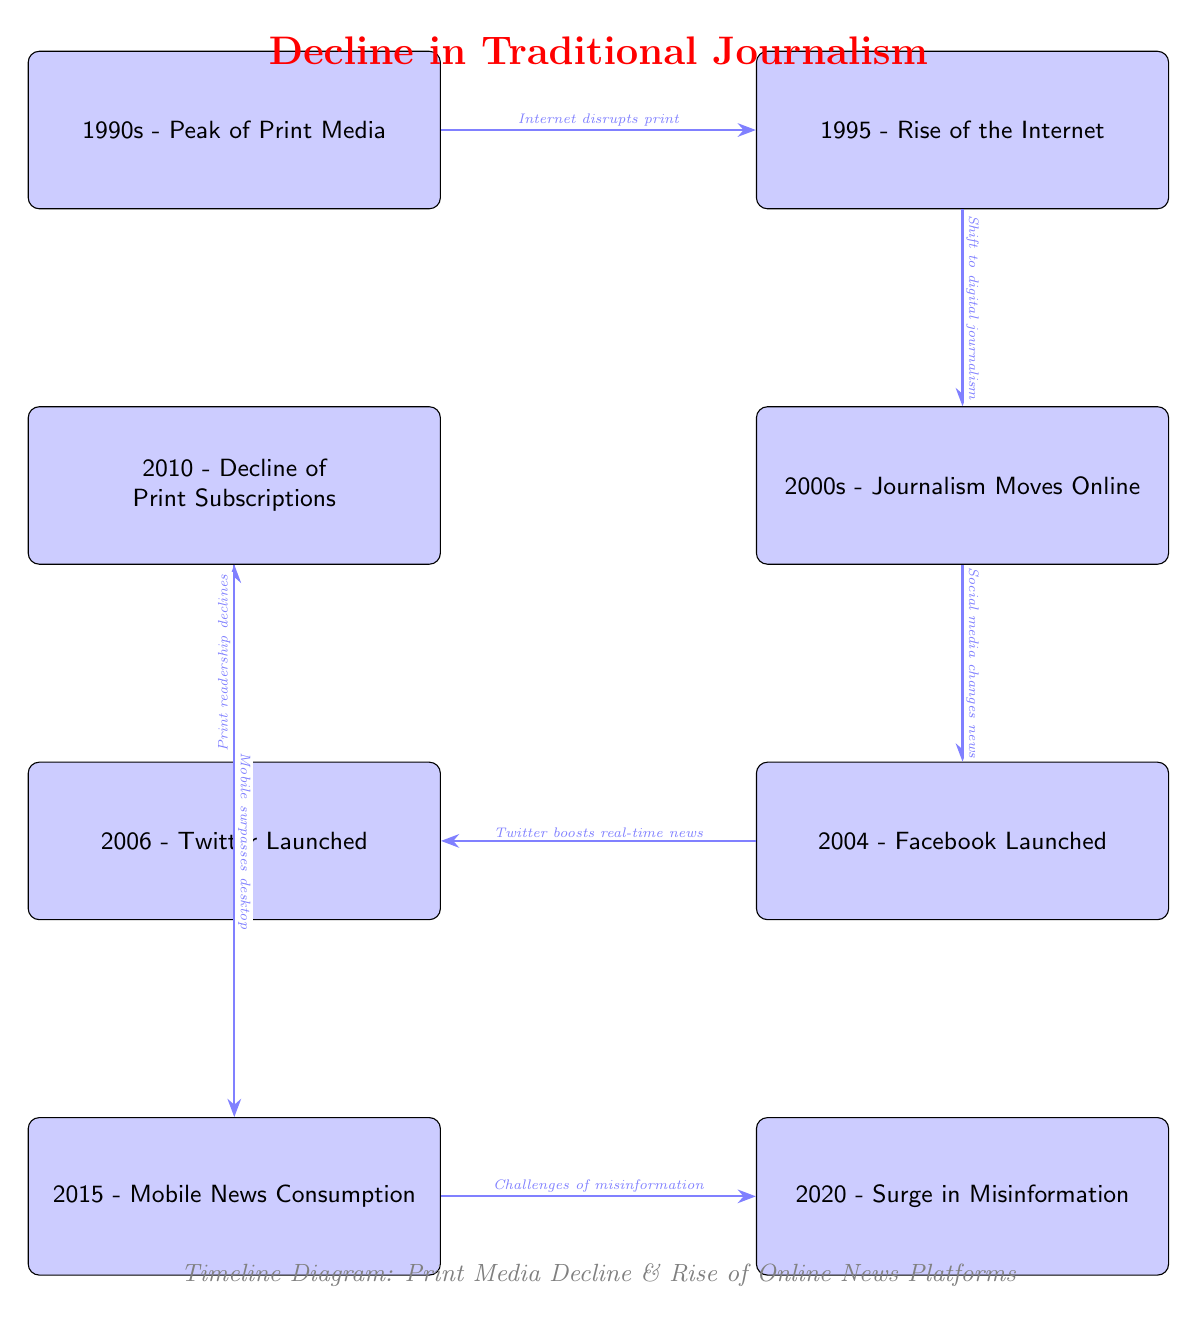What year did the rise of the Internet occur? The diagram shows a timeline with the event "Rise of the Internet" marked in the year 1995. This event is positioned directly to the right of the "Peak of Print Media" in the timeline.
Answer: 1995 What event happens just before the "Decline of Print Subscriptions"? The diagram indicates that the "Decline of Print Subscriptions" occurs in 2010, and directly above this event is the "Journalism Moves Online" event in the year 2000. This relationship shows the transition from traditional journalism to online formats leading up to the decline.
Answer: Journalism Moves Online How many major events are featured in the diagram? By counting the nodes labeled with events, there are eight key events depicted in the timeline from 1990s to 2020. Each node represents a different significant moment regarding traditional journalism's decline and the rise of online platforms.
Answer: 8 What is described as the cause of the "Print readership declines"? According to the diagram, the arrow connecting "Twitter Launched" in 2006 to "Decline of Print Subscriptions" in 2010 states "Print readership declines" and indicates the role of social media in this process. This shows how the launch of Twitter is associated with the decline in print readership.
Answer: Twitter Launched What is the relationship between mobile news consumption and misinformation? The diagram illustrates that the event "Mobile News Consumption" in 2015 leads to the "Surge in Misinformation" in 2020, indicating that the shift to mobile platforms has been linked to an increase in misinformation over time. This relationship suggests a direct progression in how news consumption has evolved.
Answer: Mobile News Consumption What significant technological change occurred in 2004? The timeline highlights that in 2004, the event labeled "Facebook Launched" took place. This introduction of a major social media platform is significant as it changed how news is shared and consumed on online platforms, marking a turning point in journalism.
Answer: Facebook Launched What transition is indicated by the arrow between "2010 - Decline of Print Subscriptions" and "2015 - Mobile News Consumption"? The diagram presents an arrow labeled "Mobile surpasses desktop" connecting the decline in print subscriptions to the rise of mobile news consumption, indicating a clear transition in user habits favoring mobile devices over traditional print media and desktop consumption.
Answer: Mobile surpasses desktop Which two social media platforms are identified in the diagram? The diagram specifically identifies two social media platforms: "Facebook Launched" in 2004 and "Twitter Launched" in 2006. Both are positioned as events that contributed to changes in news journalism, marking their significance in the timeline.
Answer: Facebook, Twitter What trend does the event "Surge in Misinformation" represent, and what year does it occur? In the timeline, the event "Surge in Misinformation" represents the challenges faced in journalism due to the rise of false information online, and it occurs in the year 2020. This event serves as a cautionary note regarding the consequences of rapid online news consumption.
Answer: 2020 